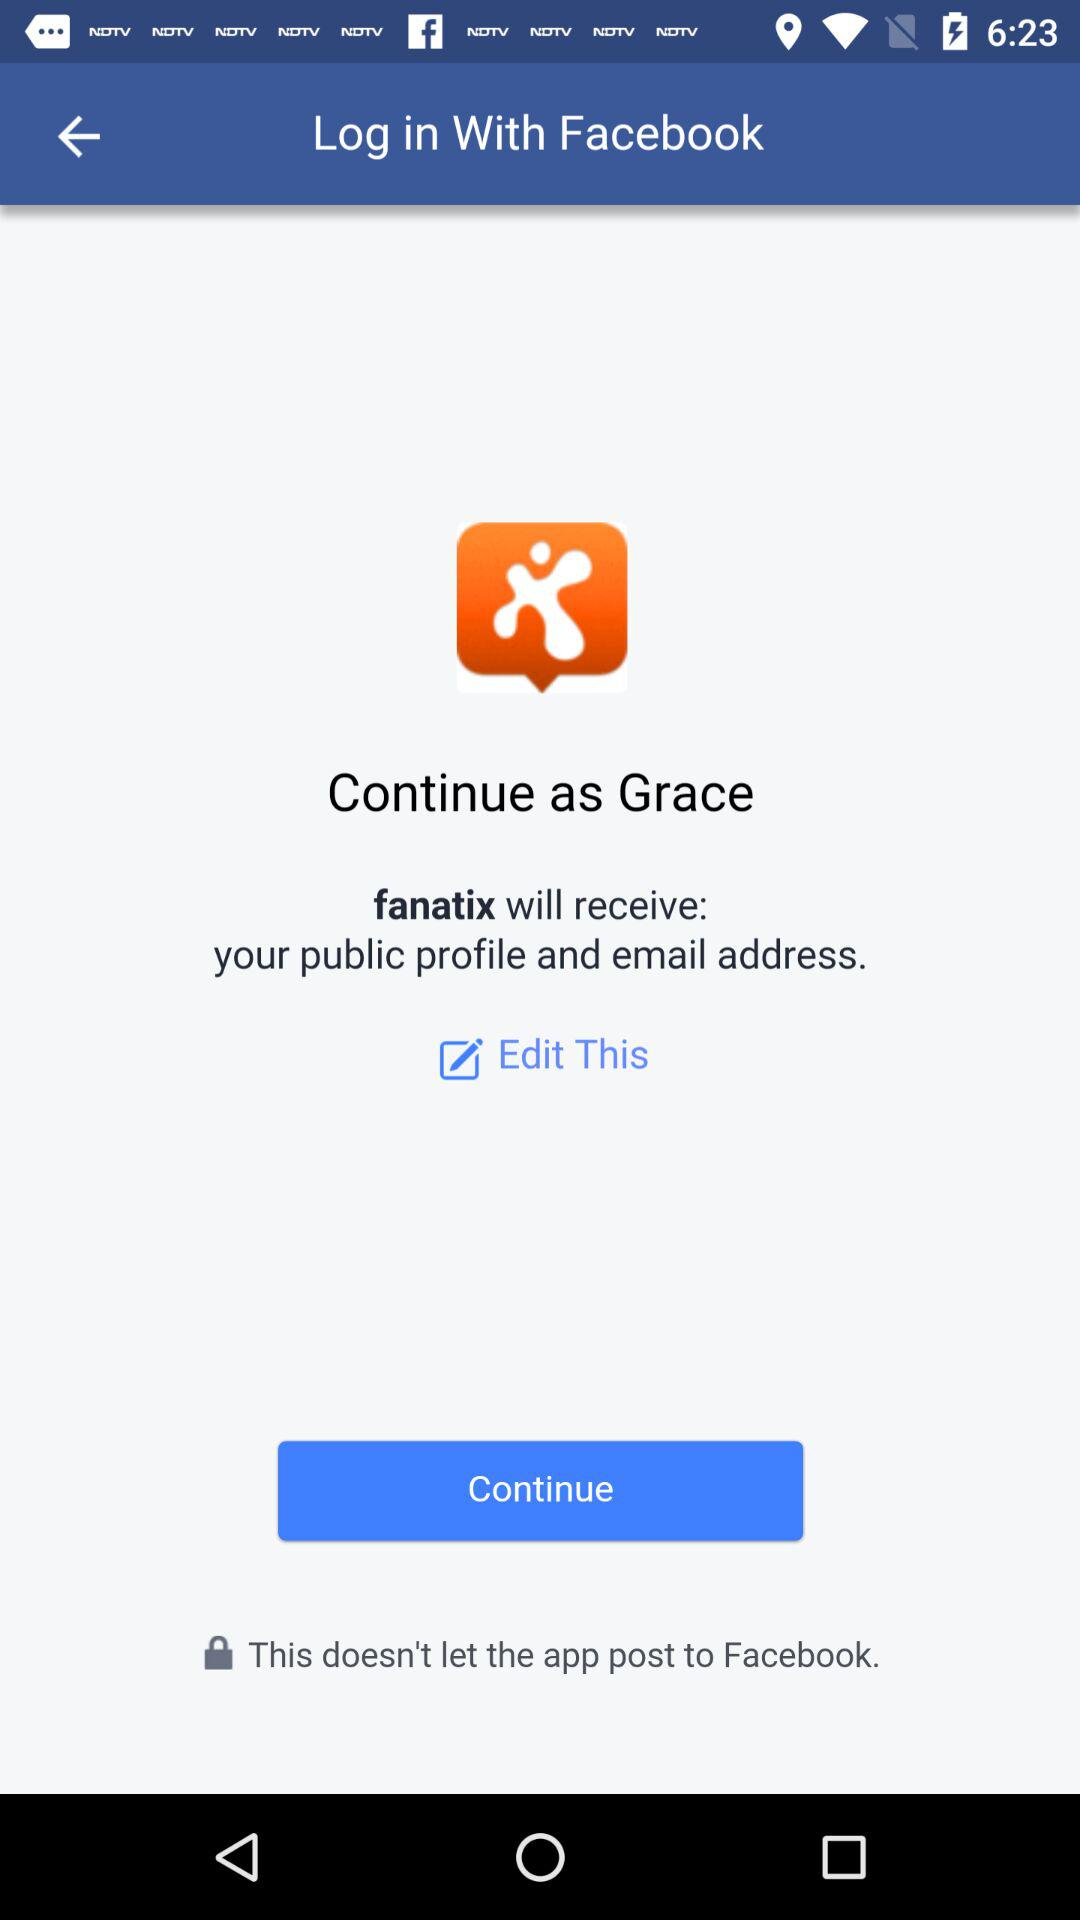What application is asking for permission? The application is "fanatix". 